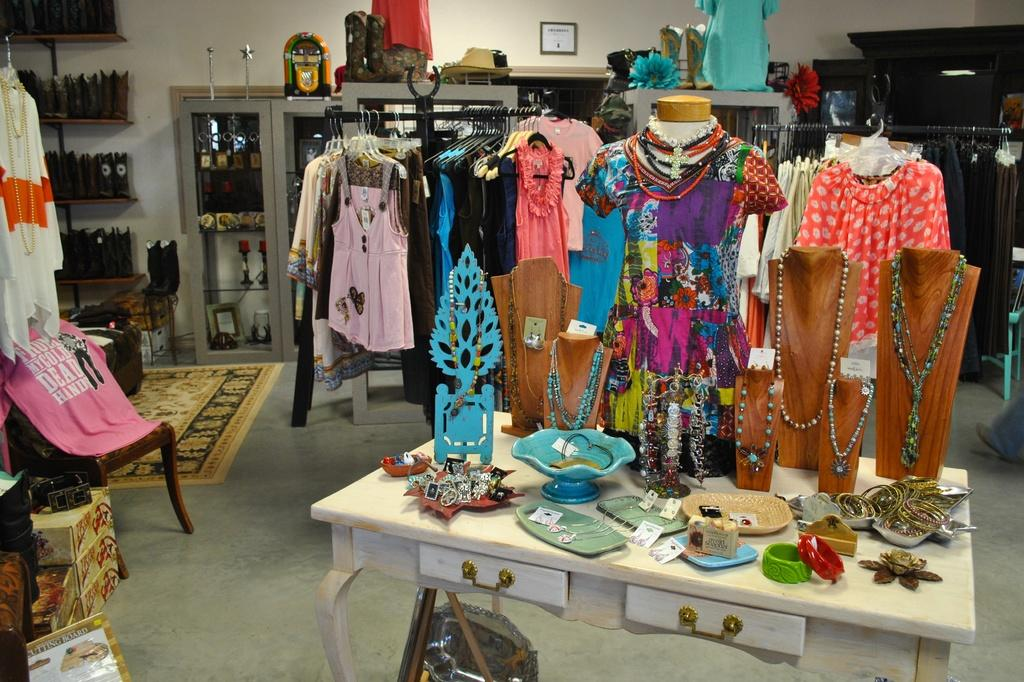What is placed on the table in the image? There is jewelry placed on a table in the image. What can be seen in the background of the image? There are many clothes hanged in the background of the image. What type of map is visible on the table next to the jewelry? There is no map present in the image; it only features jewelry placed on a table and clothes hanged in the background. 